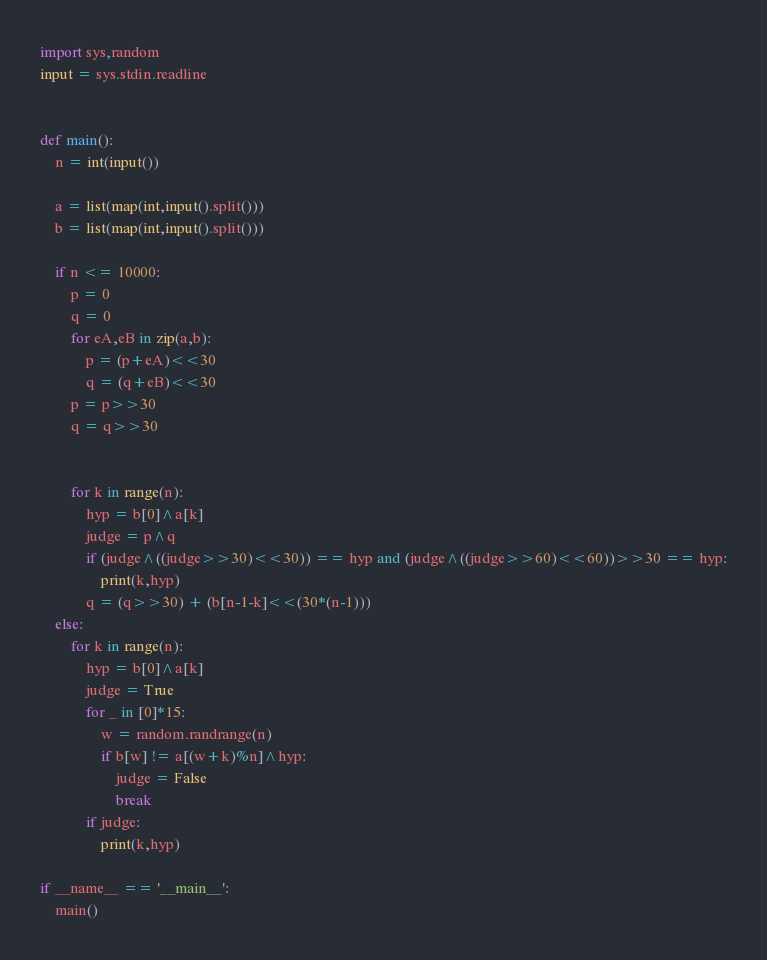Convert code to text. <code><loc_0><loc_0><loc_500><loc_500><_Python_>import sys,random
input = sys.stdin.readline


def main():
    n = int(input())
    
    a = list(map(int,input().split()))
    b = list(map(int,input().split()))

    if n <= 10000:
        p = 0
        q = 0
        for eA,eB in zip(a,b):
            p = (p+eA)<<30
            q = (q+eB)<<30
        p = p>>30
        q = q>>30


        for k in range(n):
            hyp = b[0]^a[k]
            judge = p^q
            if (judge^((judge>>30)<<30)) == hyp and (judge^((judge>>60)<<60))>>30 == hyp:
                print(k,hyp)
            q = (q>>30) + (b[n-1-k]<<(30*(n-1)))
    else:
        for k in range(n):
            hyp = b[0]^a[k]
            judge = True
            for _ in [0]*15:
                w = random.randrange(n)
                if b[w] != a[(w+k)%n]^hyp:
                    judge = False
                    break
            if judge:
                print(k,hyp)

if __name__ == '__main__':
    main()
</code> 